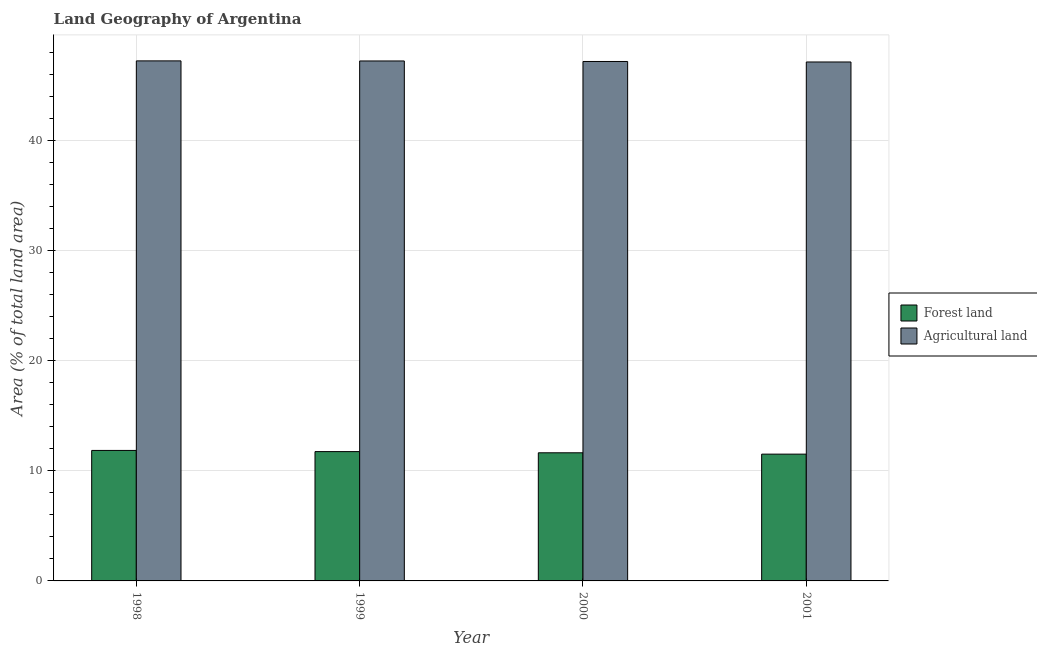Are the number of bars per tick equal to the number of legend labels?
Your answer should be compact. Yes. Are the number of bars on each tick of the X-axis equal?
Provide a short and direct response. Yes. How many bars are there on the 1st tick from the left?
Offer a terse response. 2. How many bars are there on the 4th tick from the right?
Your answer should be very brief. 2. What is the label of the 3rd group of bars from the left?
Give a very brief answer. 2000. In how many cases, is the number of bars for a given year not equal to the number of legend labels?
Provide a short and direct response. 0. What is the percentage of land area under agriculture in 2000?
Provide a short and direct response. 47.19. Across all years, what is the maximum percentage of land area under agriculture?
Offer a very short reply. 47.25. Across all years, what is the minimum percentage of land area under forests?
Keep it short and to the point. 11.52. In which year was the percentage of land area under forests maximum?
Your response must be concise. 1998. In which year was the percentage of land area under agriculture minimum?
Your answer should be very brief. 2001. What is the total percentage of land area under forests in the graph?
Your response must be concise. 46.77. What is the difference between the percentage of land area under forests in 1999 and that in 2000?
Provide a short and direct response. 0.11. What is the difference between the percentage of land area under agriculture in 2001 and the percentage of land area under forests in 1998?
Provide a succinct answer. -0.1. What is the average percentage of land area under forests per year?
Provide a succinct answer. 11.69. In the year 2000, what is the difference between the percentage of land area under forests and percentage of land area under agriculture?
Provide a short and direct response. 0. In how many years, is the percentage of land area under agriculture greater than 26 %?
Your response must be concise. 4. What is the ratio of the percentage of land area under agriculture in 1998 to that in 2000?
Offer a terse response. 1. What is the difference between the highest and the second highest percentage of land area under forests?
Your response must be concise. 0.11. What is the difference between the highest and the lowest percentage of land area under forests?
Your answer should be compact. 0.34. Is the sum of the percentage of land area under agriculture in 2000 and 2001 greater than the maximum percentage of land area under forests across all years?
Your answer should be compact. Yes. What does the 2nd bar from the left in 2000 represents?
Ensure brevity in your answer.  Agricultural land. What does the 1st bar from the right in 1998 represents?
Provide a succinct answer. Agricultural land. How many bars are there?
Your response must be concise. 8. Are the values on the major ticks of Y-axis written in scientific E-notation?
Give a very brief answer. No. Does the graph contain any zero values?
Provide a short and direct response. No. Where does the legend appear in the graph?
Offer a terse response. Center right. How many legend labels are there?
Provide a short and direct response. 2. What is the title of the graph?
Keep it short and to the point. Land Geography of Argentina. Does "Frequency of shipment arrival" appear as one of the legend labels in the graph?
Offer a terse response. No. What is the label or title of the Y-axis?
Your answer should be compact. Area (% of total land area). What is the Area (% of total land area) of Forest land in 1998?
Your answer should be very brief. 11.86. What is the Area (% of total land area) of Agricultural land in 1998?
Ensure brevity in your answer.  47.25. What is the Area (% of total land area) in Forest land in 1999?
Make the answer very short. 11.75. What is the Area (% of total land area) of Agricultural land in 1999?
Keep it short and to the point. 47.24. What is the Area (% of total land area) of Forest land in 2000?
Ensure brevity in your answer.  11.64. What is the Area (% of total land area) in Agricultural land in 2000?
Give a very brief answer. 47.19. What is the Area (% of total land area) of Forest land in 2001?
Provide a succinct answer. 11.52. What is the Area (% of total land area) in Agricultural land in 2001?
Your answer should be very brief. 47.15. Across all years, what is the maximum Area (% of total land area) of Forest land?
Provide a succinct answer. 11.86. Across all years, what is the maximum Area (% of total land area) of Agricultural land?
Your answer should be very brief. 47.25. Across all years, what is the minimum Area (% of total land area) in Forest land?
Your response must be concise. 11.52. Across all years, what is the minimum Area (% of total land area) in Agricultural land?
Provide a short and direct response. 47.15. What is the total Area (% of total land area) in Forest land in the graph?
Keep it short and to the point. 46.77. What is the total Area (% of total land area) in Agricultural land in the graph?
Make the answer very short. 188.83. What is the difference between the Area (% of total land area) of Forest land in 1998 and that in 1999?
Provide a succinct answer. 0.11. What is the difference between the Area (% of total land area) in Agricultural land in 1998 and that in 1999?
Your answer should be compact. 0.01. What is the difference between the Area (% of total land area) in Forest land in 1998 and that in 2000?
Keep it short and to the point. 0.21. What is the difference between the Area (% of total land area) of Agricultural land in 1998 and that in 2000?
Provide a short and direct response. 0.05. What is the difference between the Area (% of total land area) of Forest land in 1998 and that in 2001?
Your response must be concise. 0.34. What is the difference between the Area (% of total land area) in Agricultural land in 1998 and that in 2001?
Provide a short and direct response. 0.1. What is the difference between the Area (% of total land area) in Forest land in 1999 and that in 2000?
Provide a short and direct response. 0.11. What is the difference between the Area (% of total land area) of Agricultural land in 1999 and that in 2000?
Provide a succinct answer. 0.05. What is the difference between the Area (% of total land area) in Forest land in 1999 and that in 2001?
Ensure brevity in your answer.  0.23. What is the difference between the Area (% of total land area) of Agricultural land in 1999 and that in 2001?
Keep it short and to the point. 0.09. What is the difference between the Area (% of total land area) of Forest land in 2000 and that in 2001?
Offer a terse response. 0.12. What is the difference between the Area (% of total land area) in Agricultural land in 2000 and that in 2001?
Ensure brevity in your answer.  0.05. What is the difference between the Area (% of total land area) in Forest land in 1998 and the Area (% of total land area) in Agricultural land in 1999?
Keep it short and to the point. -35.38. What is the difference between the Area (% of total land area) in Forest land in 1998 and the Area (% of total land area) in Agricultural land in 2000?
Offer a very short reply. -35.34. What is the difference between the Area (% of total land area) in Forest land in 1998 and the Area (% of total land area) in Agricultural land in 2001?
Offer a terse response. -35.29. What is the difference between the Area (% of total land area) of Forest land in 1999 and the Area (% of total land area) of Agricultural land in 2000?
Provide a succinct answer. -35.44. What is the difference between the Area (% of total land area) in Forest land in 1999 and the Area (% of total land area) in Agricultural land in 2001?
Keep it short and to the point. -35.4. What is the difference between the Area (% of total land area) in Forest land in 2000 and the Area (% of total land area) in Agricultural land in 2001?
Give a very brief answer. -35.51. What is the average Area (% of total land area) of Forest land per year?
Make the answer very short. 11.69. What is the average Area (% of total land area) of Agricultural land per year?
Keep it short and to the point. 47.21. In the year 1998, what is the difference between the Area (% of total land area) of Forest land and Area (% of total land area) of Agricultural land?
Provide a succinct answer. -35.39. In the year 1999, what is the difference between the Area (% of total land area) of Forest land and Area (% of total land area) of Agricultural land?
Your answer should be compact. -35.49. In the year 2000, what is the difference between the Area (% of total land area) of Forest land and Area (% of total land area) of Agricultural land?
Your answer should be very brief. -35.55. In the year 2001, what is the difference between the Area (% of total land area) of Forest land and Area (% of total land area) of Agricultural land?
Provide a short and direct response. -35.63. What is the ratio of the Area (% of total land area) of Forest land in 1998 to that in 1999?
Provide a succinct answer. 1.01. What is the ratio of the Area (% of total land area) of Forest land in 1998 to that in 2000?
Offer a terse response. 1.02. What is the ratio of the Area (% of total land area) in Forest land in 1998 to that in 2001?
Ensure brevity in your answer.  1.03. What is the ratio of the Area (% of total land area) in Agricultural land in 1998 to that in 2001?
Your answer should be compact. 1. What is the ratio of the Area (% of total land area) in Forest land in 1999 to that in 2000?
Your response must be concise. 1.01. What is the ratio of the Area (% of total land area) of Agricultural land in 1999 to that in 2000?
Make the answer very short. 1. What is the ratio of the Area (% of total land area) of Forest land in 1999 to that in 2001?
Your answer should be compact. 1.02. What is the ratio of the Area (% of total land area) in Agricultural land in 1999 to that in 2001?
Ensure brevity in your answer.  1. What is the ratio of the Area (% of total land area) of Forest land in 2000 to that in 2001?
Your answer should be very brief. 1.01. What is the difference between the highest and the second highest Area (% of total land area) of Forest land?
Give a very brief answer. 0.11. What is the difference between the highest and the second highest Area (% of total land area) in Agricultural land?
Make the answer very short. 0.01. What is the difference between the highest and the lowest Area (% of total land area) in Forest land?
Ensure brevity in your answer.  0.34. What is the difference between the highest and the lowest Area (% of total land area) in Agricultural land?
Offer a terse response. 0.1. 